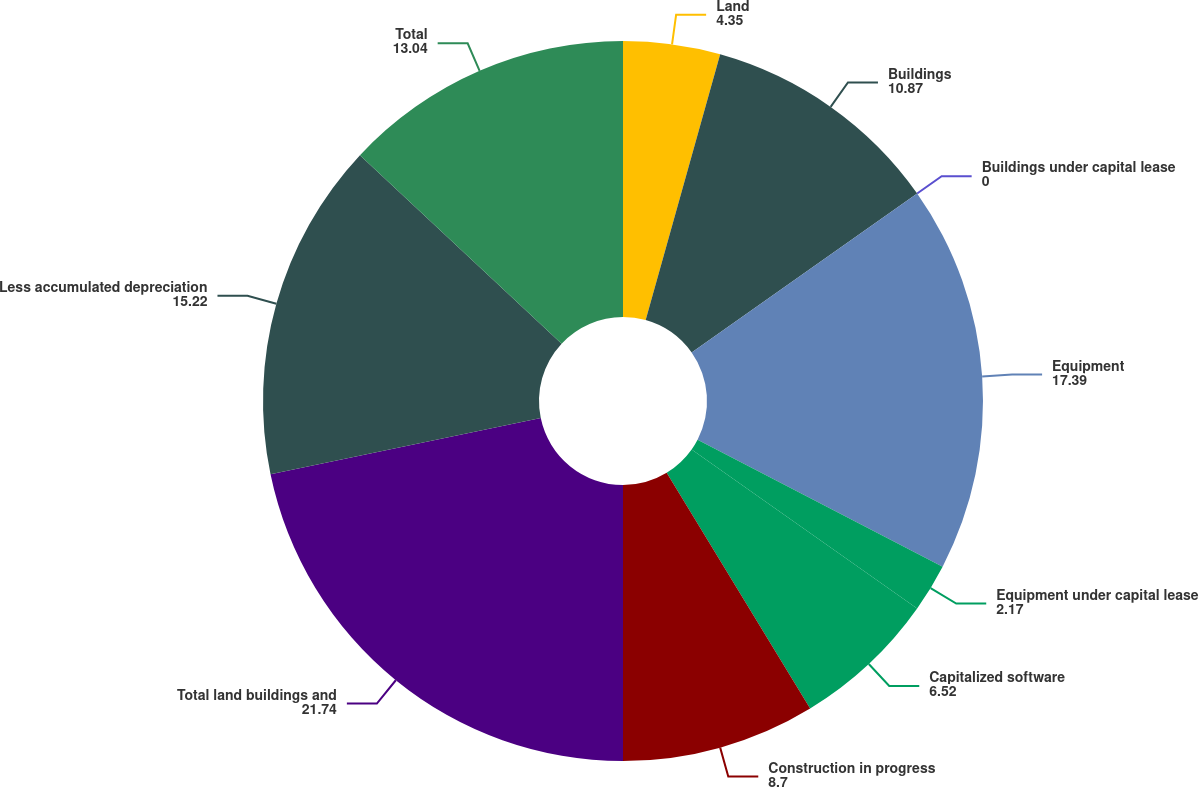Convert chart to OTSL. <chart><loc_0><loc_0><loc_500><loc_500><pie_chart><fcel>Land<fcel>Buildings<fcel>Buildings under capital lease<fcel>Equipment<fcel>Equipment under capital lease<fcel>Capitalized software<fcel>Construction in progress<fcel>Total land buildings and<fcel>Less accumulated depreciation<fcel>Total<nl><fcel>4.35%<fcel>10.87%<fcel>0.0%<fcel>17.39%<fcel>2.17%<fcel>6.52%<fcel>8.7%<fcel>21.74%<fcel>15.22%<fcel>13.04%<nl></chart> 